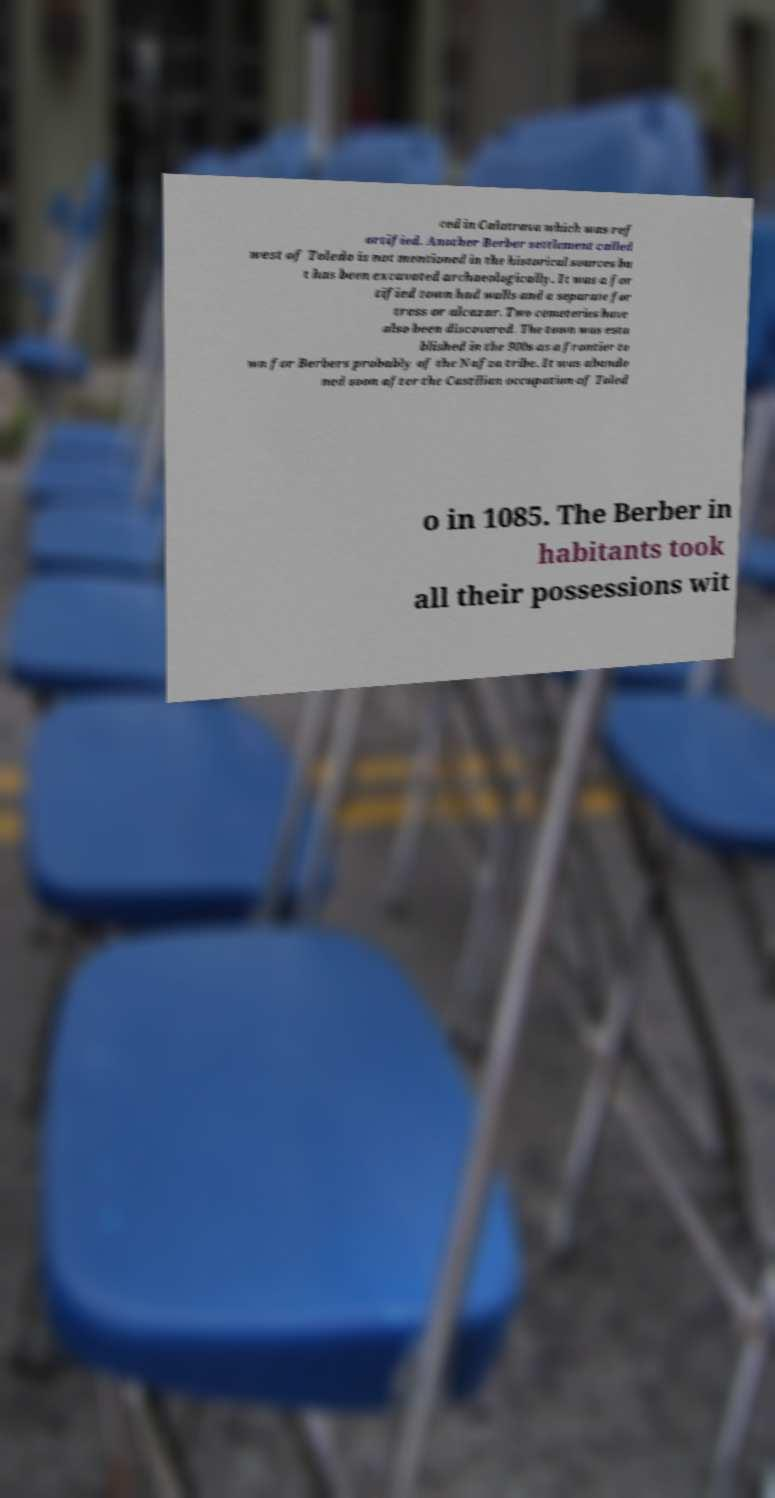Could you extract and type out the text from this image? ced in Calatrava which was ref ortified. Another Berber settlement called west of Toledo is not mentioned in the historical sources bu t has been excavated archaeologically. It was a for tified town had walls and a separate for tress or alcazar. Two cemeteries have also been discovered. The town was esta blished in the 900s as a frontier to wn for Berbers probably of the Nafza tribe. It was abando ned soon after the Castilian occupation of Toled o in 1085. The Berber in habitants took all their possessions wit 